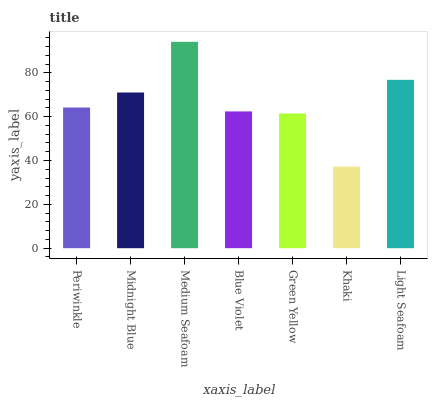Is Midnight Blue the minimum?
Answer yes or no. No. Is Midnight Blue the maximum?
Answer yes or no. No. Is Midnight Blue greater than Periwinkle?
Answer yes or no. Yes. Is Periwinkle less than Midnight Blue?
Answer yes or no. Yes. Is Periwinkle greater than Midnight Blue?
Answer yes or no. No. Is Midnight Blue less than Periwinkle?
Answer yes or no. No. Is Periwinkle the high median?
Answer yes or no. Yes. Is Periwinkle the low median?
Answer yes or no. Yes. Is Medium Seafoam the high median?
Answer yes or no. No. Is Green Yellow the low median?
Answer yes or no. No. 